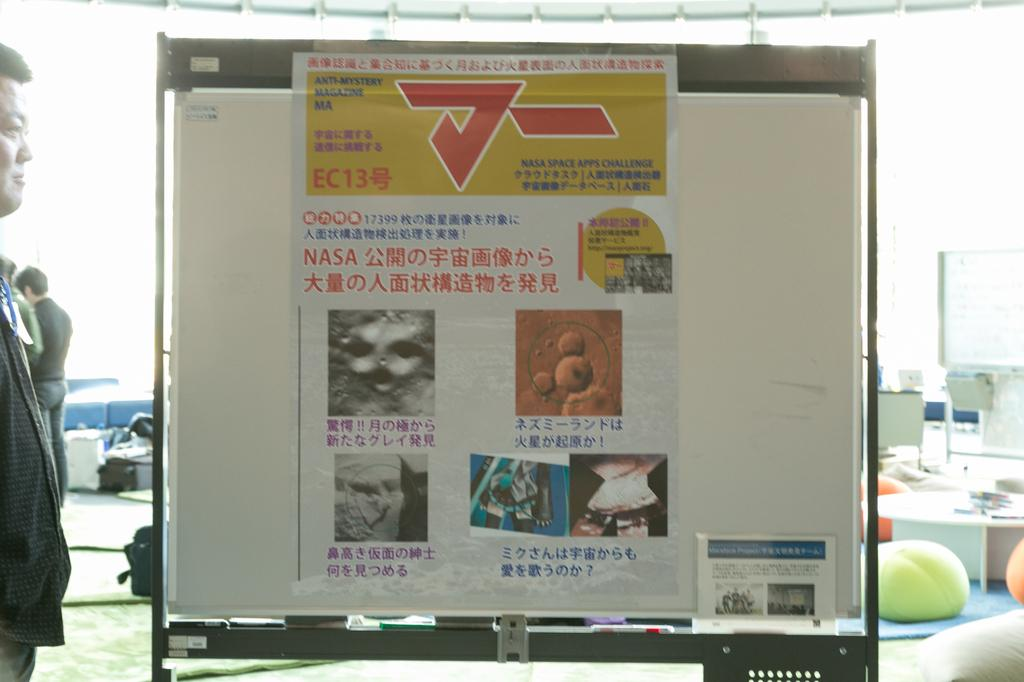<image>
Summarize the visual content of the image. A sign about the NASA Space APPS Challenge features several photos. 